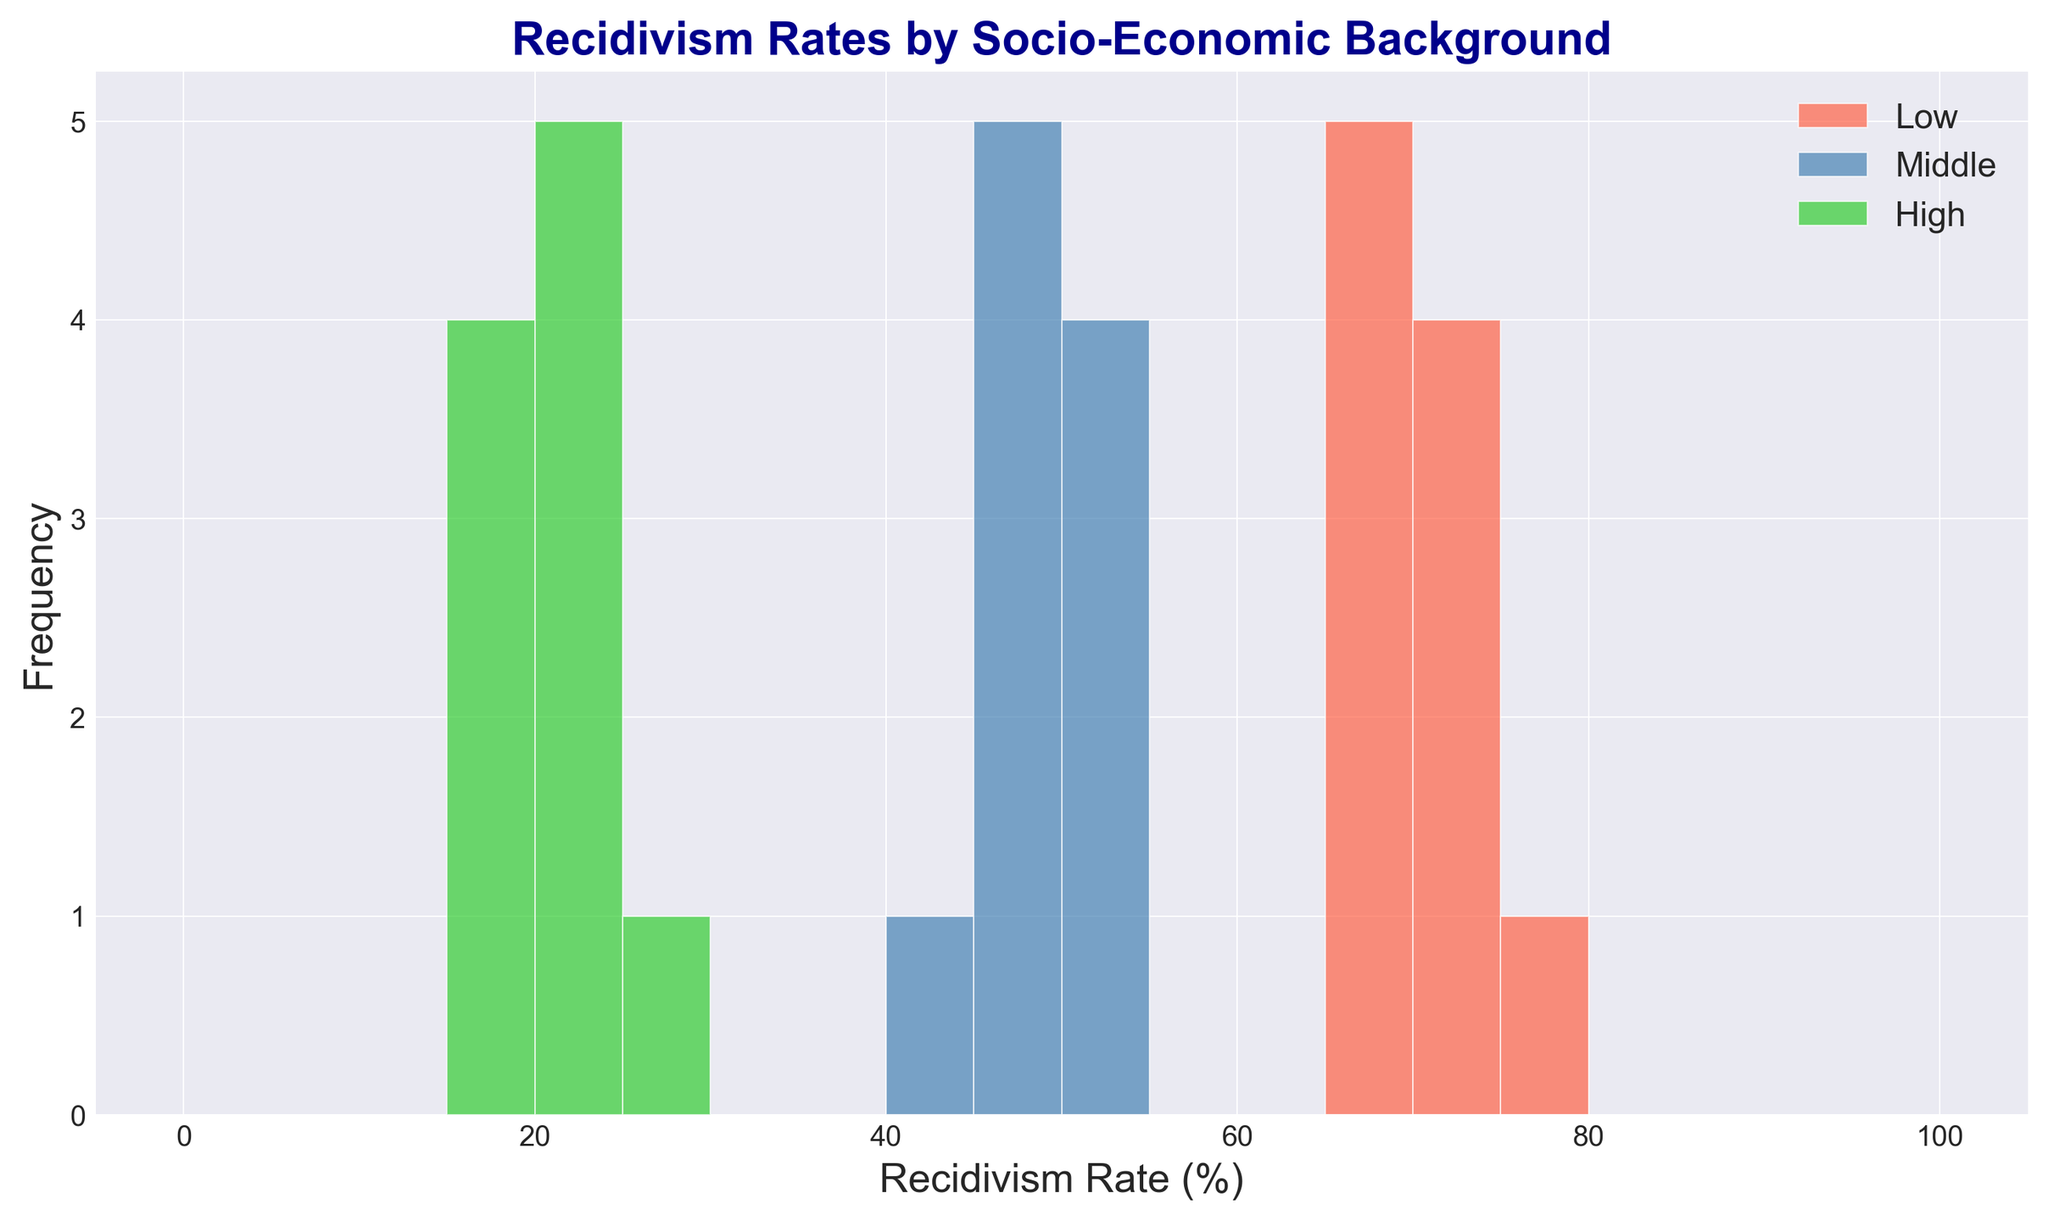Which socio-economic group has the highest recidivism rates? The figure shows recidivism rates distributed among Low, Middle, and High socio-economic backgrounds. The tallest bars in the histogram for the Low background group are higher than those for Middle and High backgrounds, indicating the highest recidivism rates.
Answer: Low Which socio-economic group has the lowest recidivism rates? The histogram shows bars for each socio-economic background. The shortest bars, indicating the lowest recidivism rates, are consistently found in the High background group.
Answer: High What is the range of recidivism rates for the Low socio-economic group? In the histogram, the Low group has bars spanning from around 65% to 75%. The range is the difference between the highest and lowest values.
Answer: 10% Compare the median recidivism rates between Low and Middle socio-economic groups. Which is higher? The histogram shows the data distribution, where the middle value for Low is approximately 70% and for Middle, it is around 50%. So, the median rate for the Low group is higher.
Answer: Low Looking at the histogram, which socio-economic background has the most variation in recidivism rates? The Low background group has a wide spread of bars from around 65% to 75%, indicating more variation compared to the Middle and High groups.
Answer: Low Approximately how many offenders in the Middle socio-economic group have a recidivism rate between 45% and 50%? The bars representing the Middle group between 45% and 50% have heights indicating about 3-4 offenders each.
Answer: Around 6-8 For the Low socio-economic group, what is the approximate frequency of offenders with a recidivism rate of 70%? The height of the bar at 70% for the Low group in the histogram suggests there are about 2 offenders.
Answer: 2 Is there a noticeable overlap in recidivism rates between Middle and High socio-economic groups? Examining the histogram, there is no overlap between Middle and High groups as the Middle group starts around 44% and the High ends around 25%.
Answer: No Which socio-economic group shows the smallest frequency of offenders with recidivism rates above 50%? The High group on the histogram shows no bars (no frequency) above the 50% mark, whereas Low and Middle do.
Answer: High 